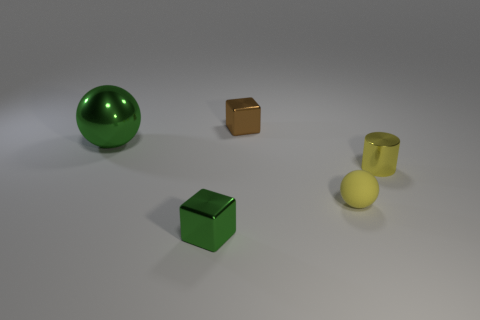Add 1 big balls. How many objects exist? 6 Subtract all spheres. How many objects are left? 3 Subtract 1 green spheres. How many objects are left? 4 Subtract all tiny brown things. Subtract all small metallic things. How many objects are left? 1 Add 3 big metallic spheres. How many big metallic spheres are left? 4 Add 4 small green blocks. How many small green blocks exist? 5 